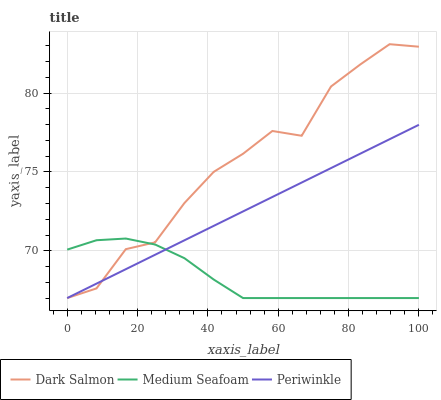Does Medium Seafoam have the minimum area under the curve?
Answer yes or no. Yes. Does Dark Salmon have the maximum area under the curve?
Answer yes or no. Yes. Does Dark Salmon have the minimum area under the curve?
Answer yes or no. No. Does Medium Seafoam have the maximum area under the curve?
Answer yes or no. No. Is Periwinkle the smoothest?
Answer yes or no. Yes. Is Dark Salmon the roughest?
Answer yes or no. Yes. Is Medium Seafoam the smoothest?
Answer yes or no. No. Is Medium Seafoam the roughest?
Answer yes or no. No. Does Dark Salmon have the highest value?
Answer yes or no. Yes. Does Medium Seafoam have the highest value?
Answer yes or no. No. Does Periwinkle intersect Dark Salmon?
Answer yes or no. Yes. Is Periwinkle less than Dark Salmon?
Answer yes or no. No. Is Periwinkle greater than Dark Salmon?
Answer yes or no. No. 